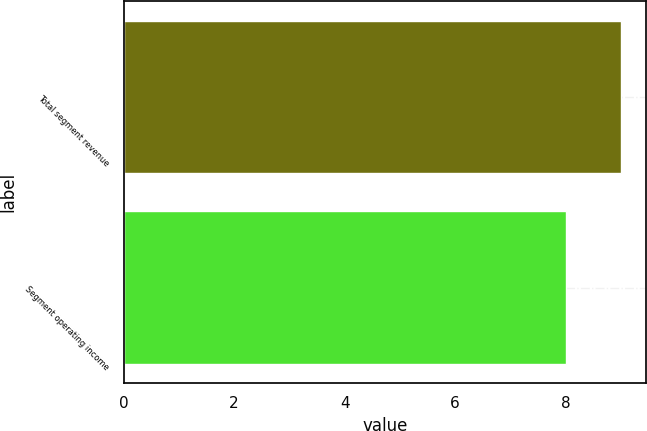Convert chart. <chart><loc_0><loc_0><loc_500><loc_500><bar_chart><fcel>Total segment revenue<fcel>Segment operating income<nl><fcel>9<fcel>8<nl></chart> 